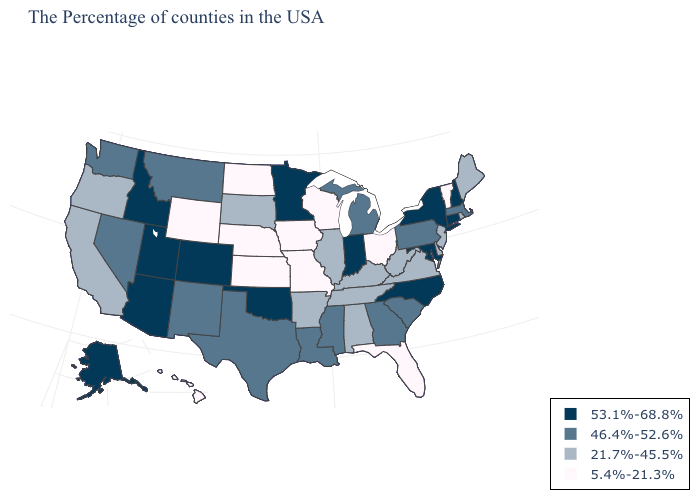Name the states that have a value in the range 53.1%-68.8%?
Concise answer only. New Hampshire, Connecticut, New York, Maryland, North Carolina, Indiana, Minnesota, Oklahoma, Colorado, Utah, Arizona, Idaho, Alaska. Is the legend a continuous bar?
Be succinct. No. Does Florida have the lowest value in the USA?
Concise answer only. Yes. What is the highest value in the South ?
Answer briefly. 53.1%-68.8%. What is the lowest value in the South?
Be succinct. 5.4%-21.3%. How many symbols are there in the legend?
Answer briefly. 4. Does Mississippi have the same value as Montana?
Answer briefly. Yes. Does Massachusetts have the same value as West Virginia?
Quick response, please. No. What is the value of Kansas?
Quick response, please. 5.4%-21.3%. What is the value of Missouri?
Concise answer only. 5.4%-21.3%. Which states have the lowest value in the USA?
Answer briefly. Vermont, Ohio, Florida, Wisconsin, Missouri, Iowa, Kansas, Nebraska, North Dakota, Wyoming, Hawaii. Among the states that border Montana , does Wyoming have the highest value?
Keep it brief. No. Among the states that border Oregon , which have the highest value?
Give a very brief answer. Idaho. What is the value of Wyoming?
Be succinct. 5.4%-21.3%. Is the legend a continuous bar?
Answer briefly. No. 